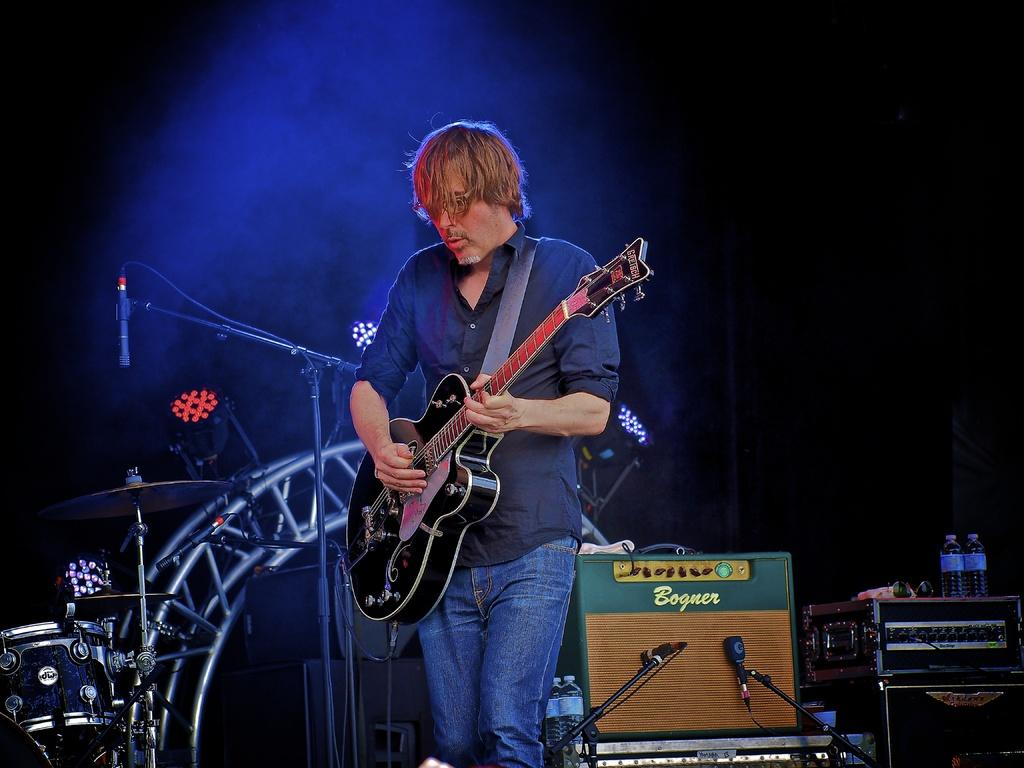What is the person in the image doing? The person is standing and playing the guitar. What object is the person holding? The person is holding a guitar. What can be seen in the background of the image? There is a microphone, musical instrument systems, water bottles, and a big stage in the background. How many dolls are sitting on the stage in the image? There are no dolls present in the image; it features a person playing the guitar on a stage with other equipment in the background. 